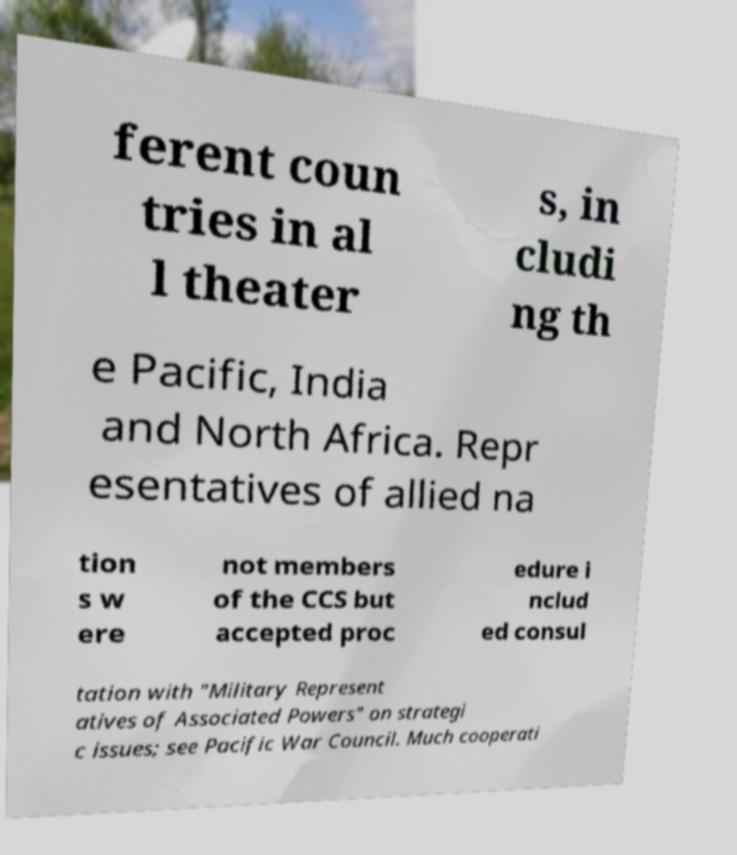Please identify and transcribe the text found in this image. ferent coun tries in al l theater s, in cludi ng th e Pacific, India and North Africa. Repr esentatives of allied na tion s w ere not members of the CCS but accepted proc edure i nclud ed consul tation with "Military Represent atives of Associated Powers" on strategi c issues; see Pacific War Council. Much cooperati 